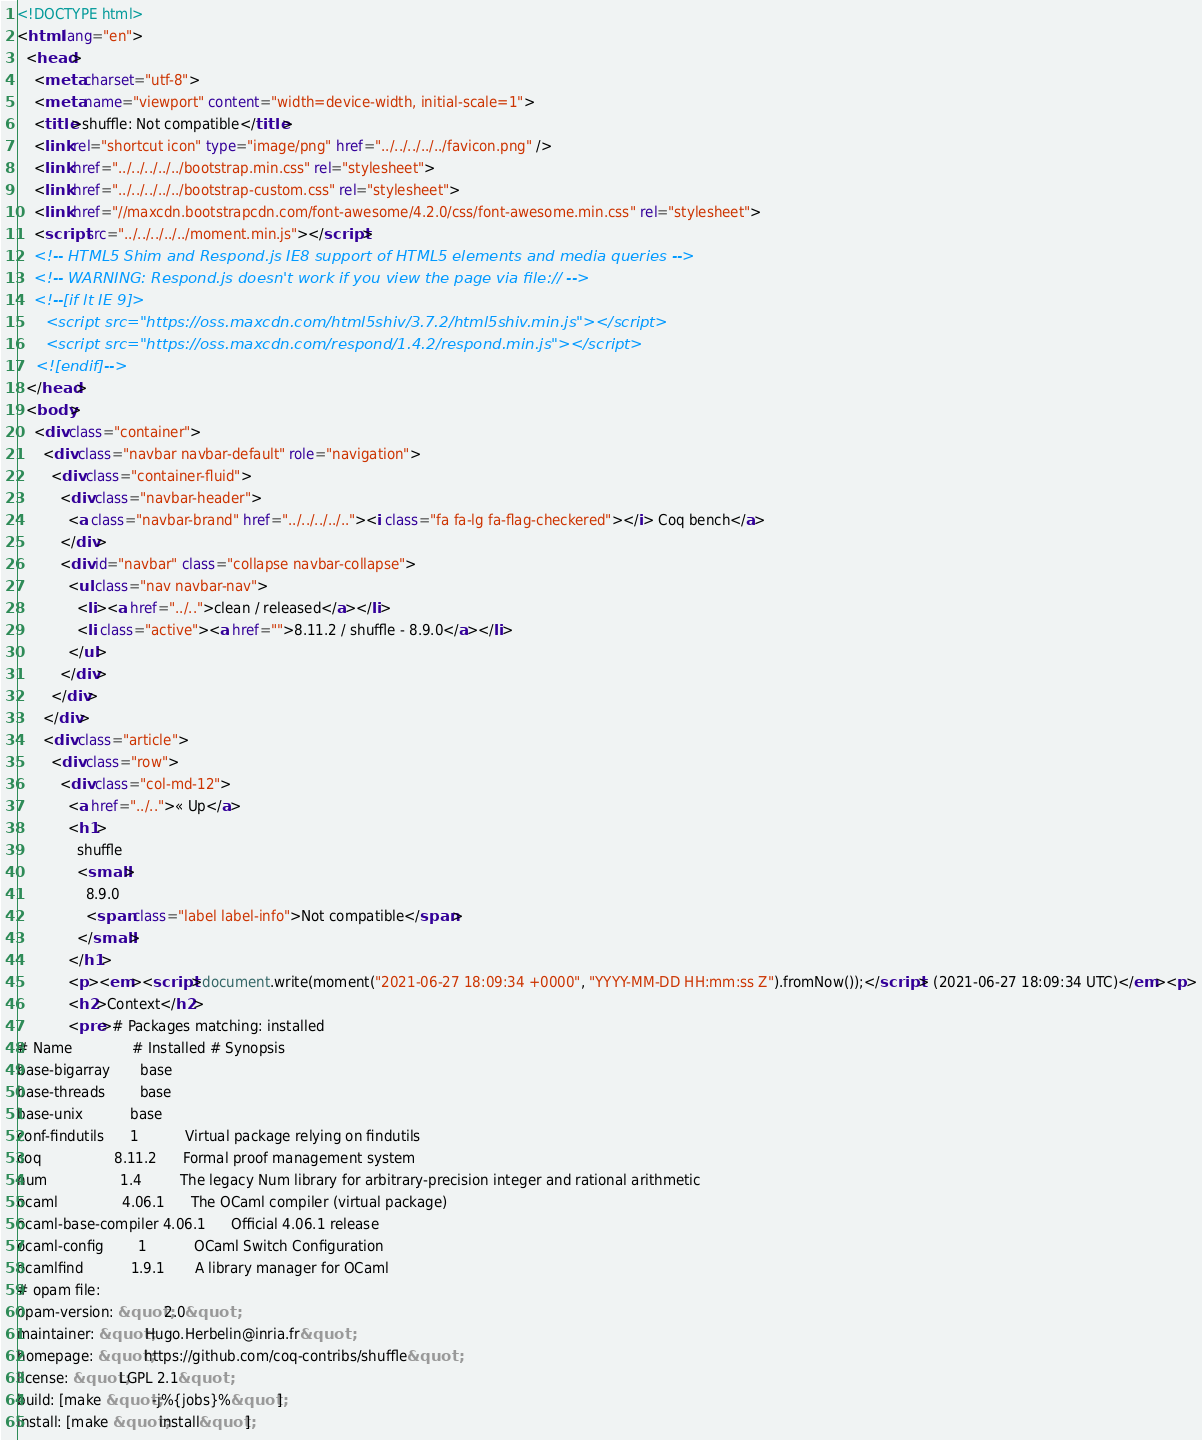<code> <loc_0><loc_0><loc_500><loc_500><_HTML_><!DOCTYPE html>
<html lang="en">
  <head>
    <meta charset="utf-8">
    <meta name="viewport" content="width=device-width, initial-scale=1">
    <title>shuffle: Not compatible</title>
    <link rel="shortcut icon" type="image/png" href="../../../../../favicon.png" />
    <link href="../../../../../bootstrap.min.css" rel="stylesheet">
    <link href="../../../../../bootstrap-custom.css" rel="stylesheet">
    <link href="//maxcdn.bootstrapcdn.com/font-awesome/4.2.0/css/font-awesome.min.css" rel="stylesheet">
    <script src="../../../../../moment.min.js"></script>
    <!-- HTML5 Shim and Respond.js IE8 support of HTML5 elements and media queries -->
    <!-- WARNING: Respond.js doesn't work if you view the page via file:// -->
    <!--[if lt IE 9]>
      <script src="https://oss.maxcdn.com/html5shiv/3.7.2/html5shiv.min.js"></script>
      <script src="https://oss.maxcdn.com/respond/1.4.2/respond.min.js"></script>
    <![endif]-->
  </head>
  <body>
    <div class="container">
      <div class="navbar navbar-default" role="navigation">
        <div class="container-fluid">
          <div class="navbar-header">
            <a class="navbar-brand" href="../../../../.."><i class="fa fa-lg fa-flag-checkered"></i> Coq bench</a>
          </div>
          <div id="navbar" class="collapse navbar-collapse">
            <ul class="nav navbar-nav">
              <li><a href="../..">clean / released</a></li>
              <li class="active"><a href="">8.11.2 / shuffle - 8.9.0</a></li>
            </ul>
          </div>
        </div>
      </div>
      <div class="article">
        <div class="row">
          <div class="col-md-12">
            <a href="../..">« Up</a>
            <h1>
              shuffle
              <small>
                8.9.0
                <span class="label label-info">Not compatible</span>
              </small>
            </h1>
            <p><em><script>document.write(moment("2021-06-27 18:09:34 +0000", "YYYY-MM-DD HH:mm:ss Z").fromNow());</script> (2021-06-27 18:09:34 UTC)</em><p>
            <h2>Context</h2>
            <pre># Packages matching: installed
# Name              # Installed # Synopsis
base-bigarray       base
base-threads        base
base-unix           base
conf-findutils      1           Virtual package relying on findutils
coq                 8.11.2      Formal proof management system
num                 1.4         The legacy Num library for arbitrary-precision integer and rational arithmetic
ocaml               4.06.1      The OCaml compiler (virtual package)
ocaml-base-compiler 4.06.1      Official 4.06.1 release
ocaml-config        1           OCaml Switch Configuration
ocamlfind           1.9.1       A library manager for OCaml
# opam file:
opam-version: &quot;2.0&quot;
maintainer: &quot;Hugo.Herbelin@inria.fr&quot;
homepage: &quot;https://github.com/coq-contribs/shuffle&quot;
license: &quot;LGPL 2.1&quot;
build: [make &quot;-j%{jobs}%&quot;]
install: [make &quot;install&quot;]</code> 